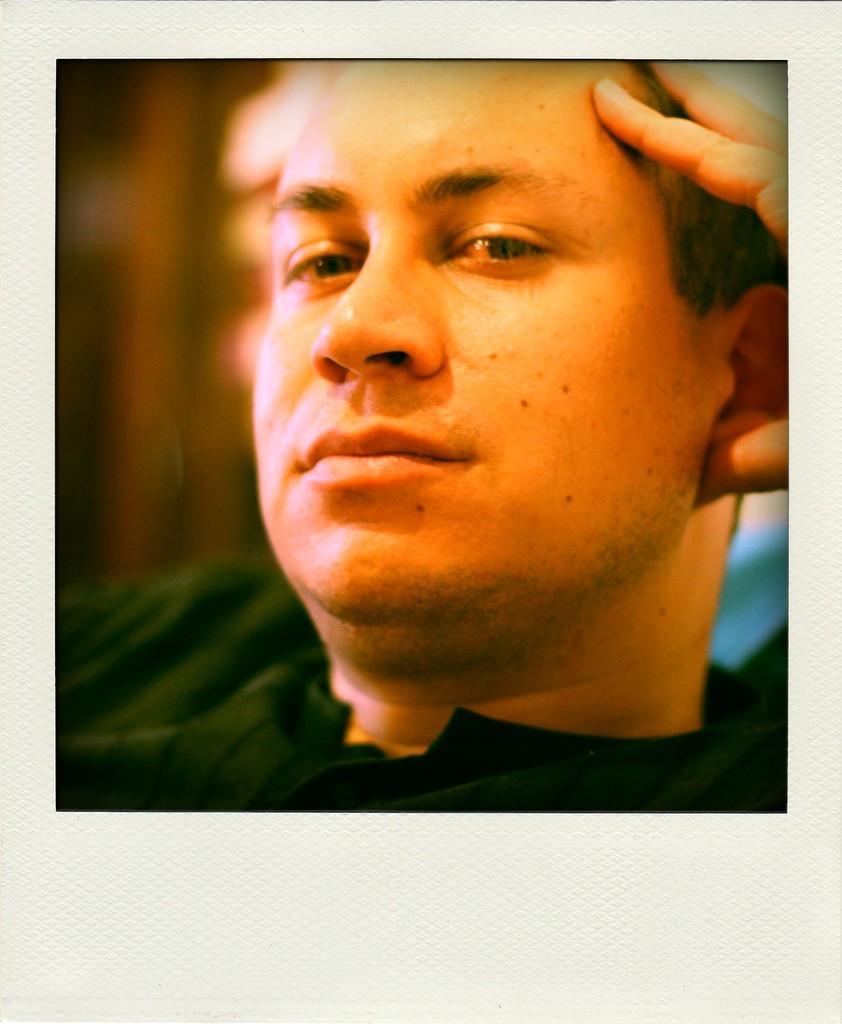In one or two sentences, can you explain what this image depicts? Here, we can see a picture of a man, he is holding his head. 